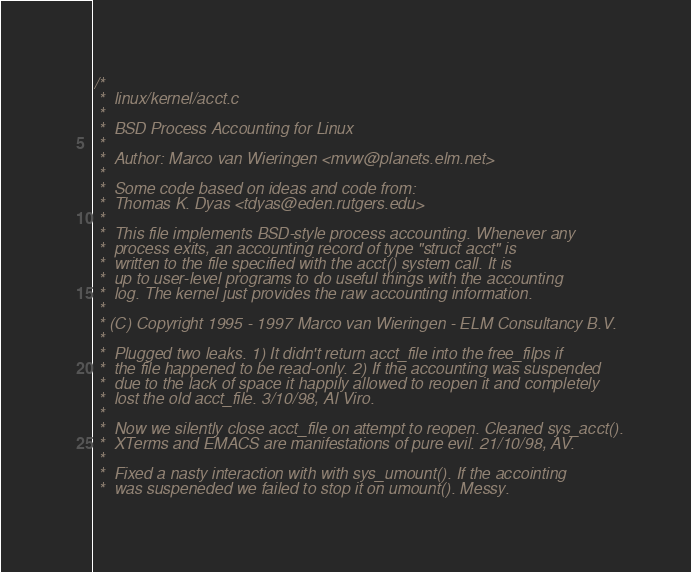<code> <loc_0><loc_0><loc_500><loc_500><_C_>/*
 *  linux/kernel/acct.c
 *
 *  BSD Process Accounting for Linux
 *
 *  Author: Marco van Wieringen <mvw@planets.elm.net>
 *
 *  Some code based on ideas and code from:
 *  Thomas K. Dyas <tdyas@eden.rutgers.edu>
 *
 *  This file implements BSD-style process accounting. Whenever any
 *  process exits, an accounting record of type "struct acct" is
 *  written to the file specified with the acct() system call. It is
 *  up to user-level programs to do useful things with the accounting
 *  log. The kernel just provides the raw accounting information.
 *
 * (C) Copyright 1995 - 1997 Marco van Wieringen - ELM Consultancy B.V.
 *
 *  Plugged two leaks. 1) It didn't return acct_file into the free_filps if
 *  the file happened to be read-only. 2) If the accounting was suspended
 *  due to the lack of space it happily allowed to reopen it and completely
 *  lost the old acct_file. 3/10/98, Al Viro.
 *
 *  Now we silently close acct_file on attempt to reopen. Cleaned sys_acct().
 *  XTerms and EMACS are manifestations of pure evil. 21/10/98, AV.
 *
 *  Fixed a nasty interaction with with sys_umount(). If the accointing
 *  was suspeneded we failed to stop it on umount(). Messy.</code> 